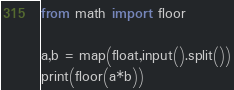Convert code to text. <code><loc_0><loc_0><loc_500><loc_500><_Python_>from math import floor
 
a,b = map(float,input().split())
print(floor(a*b))</code> 